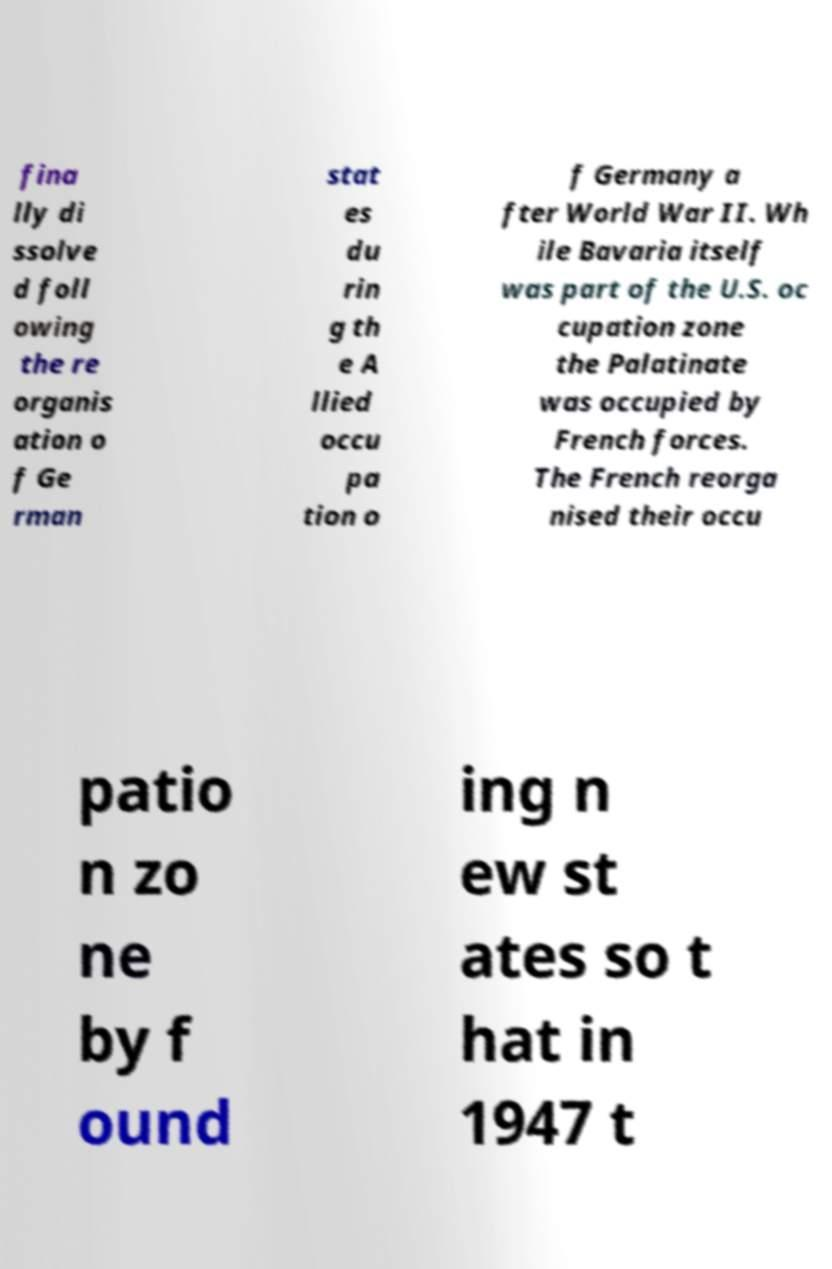Can you accurately transcribe the text from the provided image for me? fina lly di ssolve d foll owing the re organis ation o f Ge rman stat es du rin g th e A llied occu pa tion o f Germany a fter World War II. Wh ile Bavaria itself was part of the U.S. oc cupation zone the Palatinate was occupied by French forces. The French reorga nised their occu patio n zo ne by f ound ing n ew st ates so t hat in 1947 t 